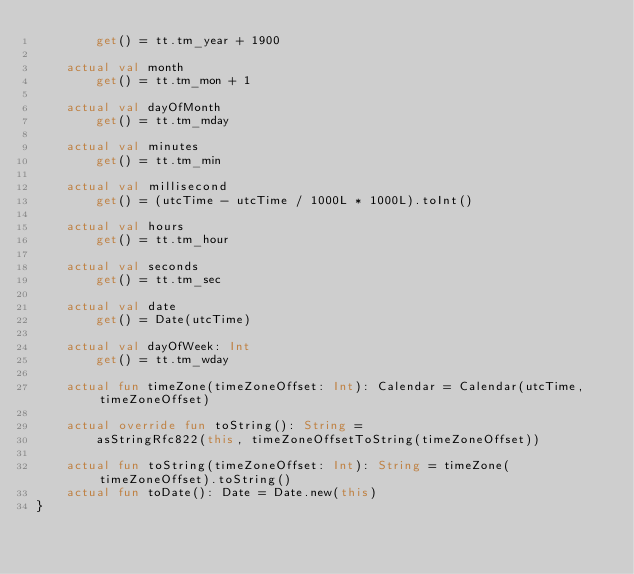Convert code to text. <code><loc_0><loc_0><loc_500><loc_500><_Kotlin_>        get() = tt.tm_year + 1900

    actual val month
        get() = tt.tm_mon + 1

    actual val dayOfMonth
        get() = tt.tm_mday

    actual val minutes
        get() = tt.tm_min

    actual val millisecond
        get() = (utcTime - utcTime / 1000L * 1000L).toInt()

    actual val hours
        get() = tt.tm_hour

    actual val seconds
        get() = tt.tm_sec

    actual val date
        get() = Date(utcTime)

    actual val dayOfWeek: Int
        get() = tt.tm_wday

    actual fun timeZone(timeZoneOffset: Int): Calendar = Calendar(utcTime, timeZoneOffset)

    actual override fun toString(): String =
        asStringRfc822(this, timeZoneOffsetToString(timeZoneOffset))

    actual fun toString(timeZoneOffset: Int): String = timeZone(timeZoneOffset).toString()
    actual fun toDate(): Date = Date.new(this)
}</code> 